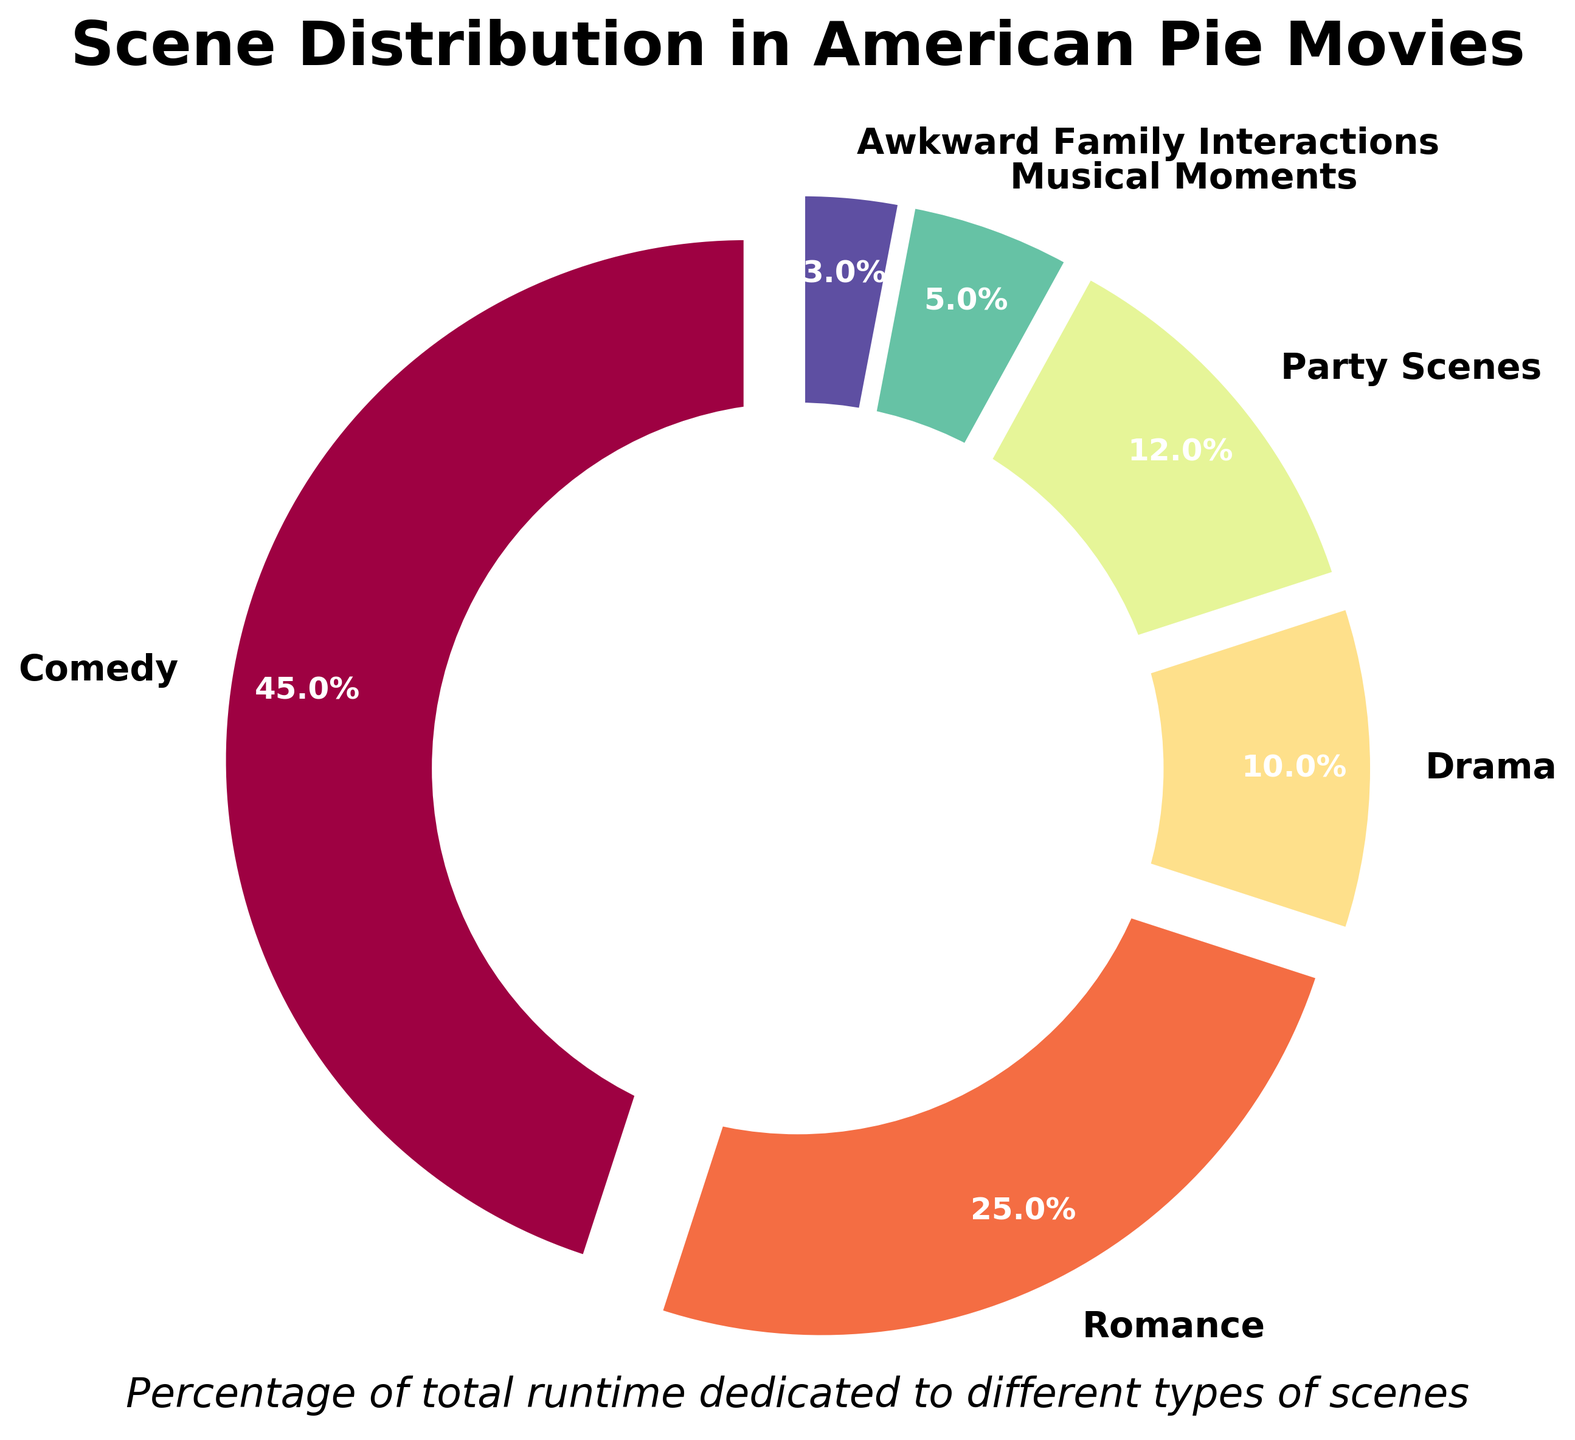Which type of scene takes up the largest percentage of the runtime? The chart shows different scene types along with their corresponding percentages. The largest percentage is 45%, which corresponds to Comedy.
Answer: Comedy Which type of scene has the second-largest percentage? By visually comparing the wedges, Romance comes next after Comedy with 25%.
Answer: Romance By how much does the percentage of Party Scenes exceed the percentage of Drama scenes? The percentage for Party Scenes is 12% and for Drama scenes is 10%. The difference is calculated as 12% - 10% = 2%.
Answer: 2% What is the combined percentage of Comedy and Romance scenes? Summing the percentages of Comedy (45%) and Romance (25%) gives 45% + 25% = 70%.
Answer: 70% Are there more Awkward Family Interactions or Drama scenes? The visualization shows 3% for Awkward Family Interactions and 10% for Drama scenes. Therefore, there are more Drama scenes.
Answer: Drama scenes How much more runtime is dedicated to Comedy scenes compared to the total percentage of Musical Moments and Awkward Family Interactions combined? The total percentage for Musical Moments is 5% and for Awkward Family Interactions is 3%. Summing these gives 5% + 3% = 8%. The difference between Comedy (45%) and this sum is 45% - 8% = 37%.
Answer: 37% Which scene type has the smallest percentage, and what is it? According to the chart, Awkward Family Interactions has the smallest percentage at 3%.
Answer: Awkward Family Interactions, 3% What is the total percentage of runtime dedicated to Drama, Party Scenes, and Musical Moments combined? Adding the percentages for Drama (10%), Party Scenes (12%), and Musical Moments (5%) gives 10% + 12% + 5% = 27%.
Answer: 27% 